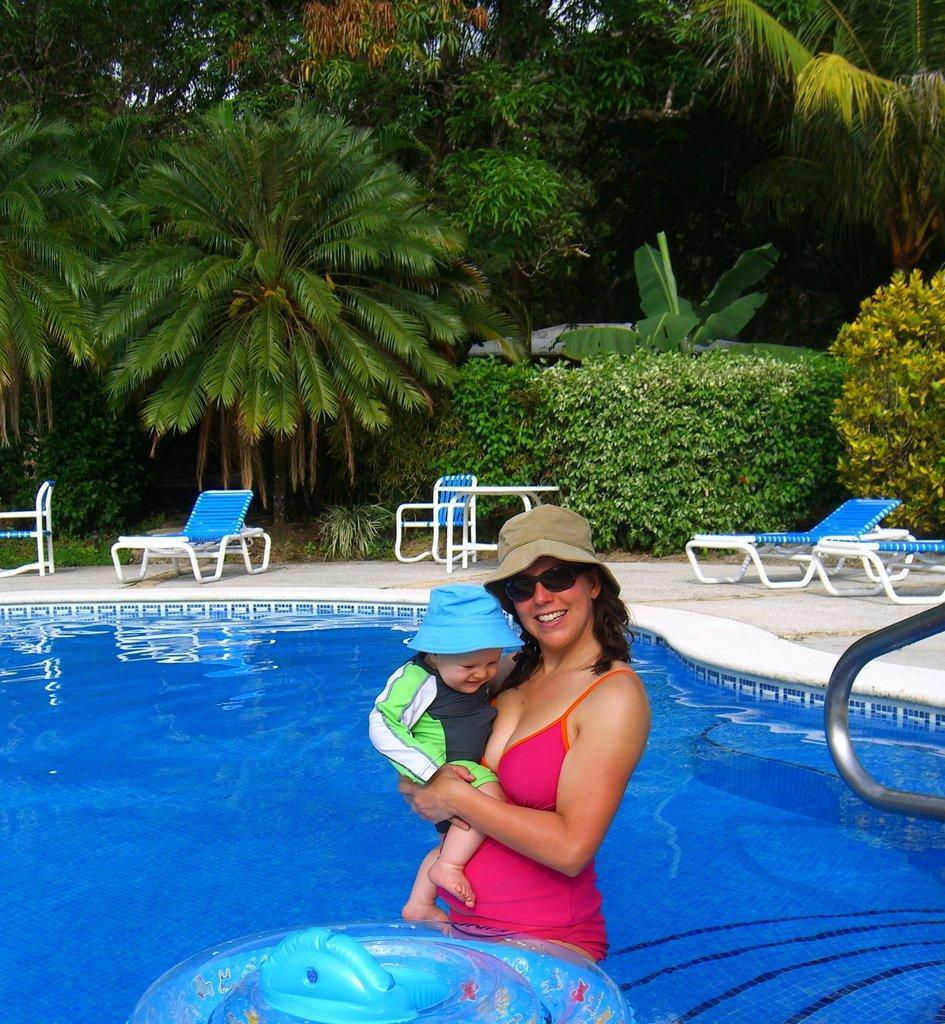How would you summarize this image in a sentence or two? In this picture we can see a woman holding a baby and looking at someone. She is standing in a pool of water surrounded by plants and trees. 